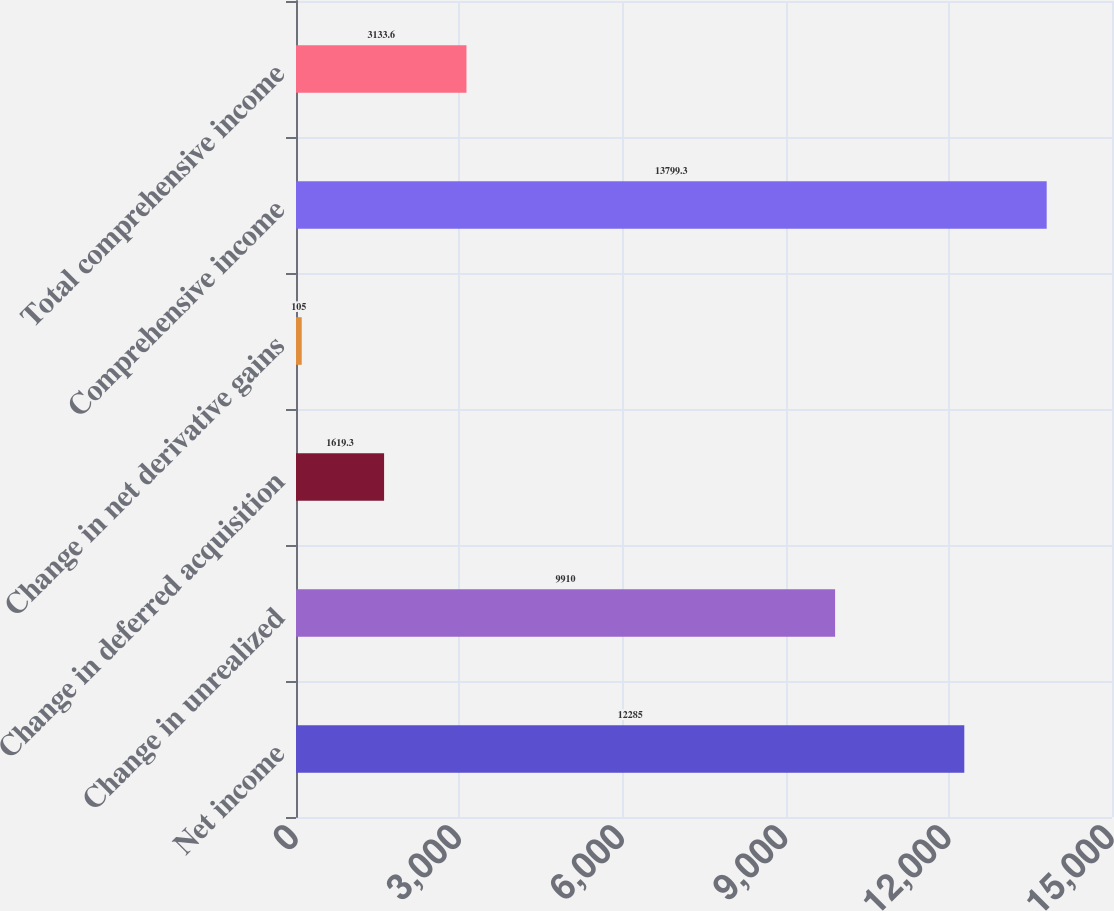Convert chart. <chart><loc_0><loc_0><loc_500><loc_500><bar_chart><fcel>Net income<fcel>Change in unrealized<fcel>Change in deferred acquisition<fcel>Change in net derivative gains<fcel>Comprehensive income<fcel>Total comprehensive income<nl><fcel>12285<fcel>9910<fcel>1619.3<fcel>105<fcel>13799.3<fcel>3133.6<nl></chart> 